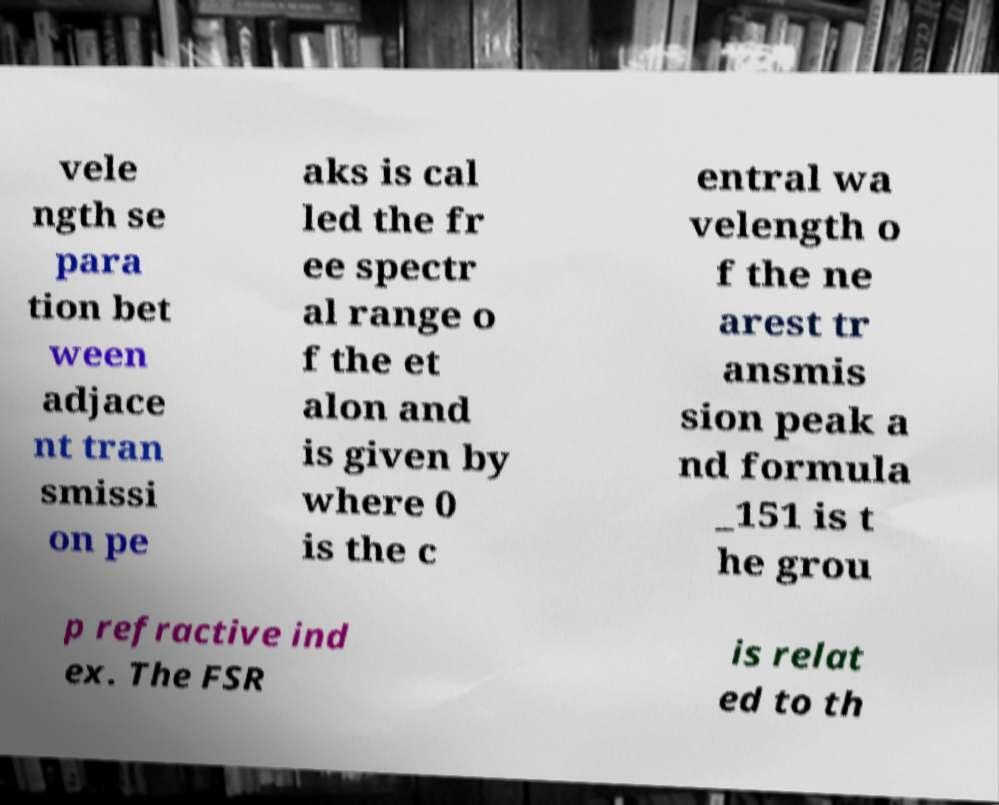Please identify and transcribe the text found in this image. vele ngth se para tion bet ween adjace nt tran smissi on pe aks is cal led the fr ee spectr al range o f the et alon and is given by where 0 is the c entral wa velength o f the ne arest tr ansmis sion peak a nd formula _151 is t he grou p refractive ind ex. The FSR is relat ed to th 